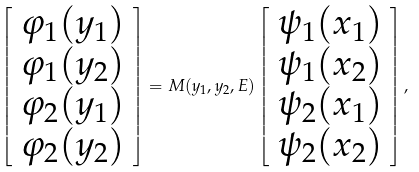<formula> <loc_0><loc_0><loc_500><loc_500>\left [ \begin{array} { c } \varphi _ { 1 } ( y _ { 1 } ) \\ \varphi _ { 1 } ( y _ { 2 } ) \\ \varphi _ { 2 } ( y _ { 1 } ) \\ \varphi _ { 2 } ( y _ { 2 } ) \end{array} \right ] = M ( y _ { 1 } , y _ { 2 } , E ) \left [ \begin{array} { c } \psi _ { 1 } ( x _ { 1 } ) \\ \psi _ { 1 } ( x _ { 2 } ) \\ \psi _ { 2 } ( x _ { 1 } ) \\ \psi _ { 2 } ( x _ { 2 } ) \end{array} \right ] ,</formula> 